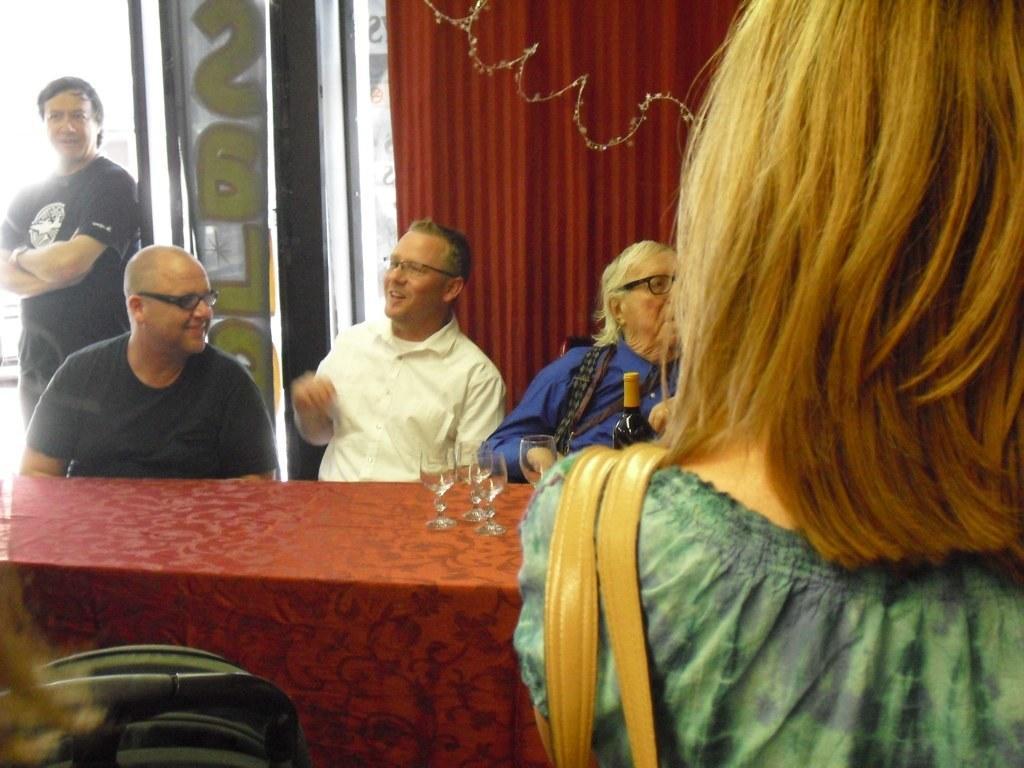How would you summarize this image in a sentence or two? In this image I can see few people where a man is standing and everyone are sitting. I can also see few people wearing specs. Here on this table I can see few glasses and a bottle. 